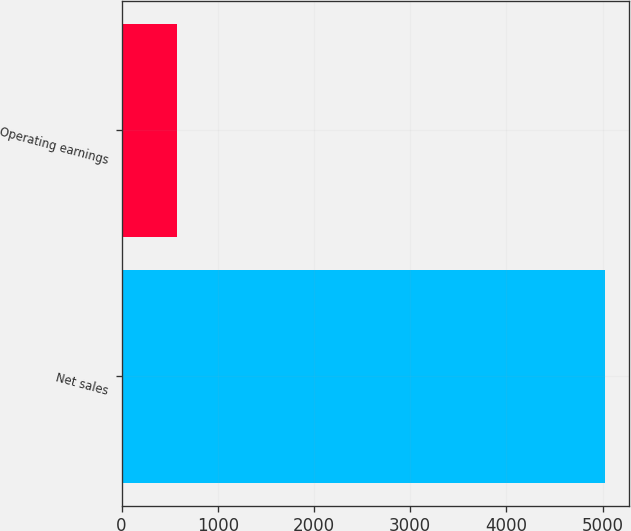<chart> <loc_0><loc_0><loc_500><loc_500><bar_chart><fcel>Net sales<fcel>Operating earnings<nl><fcel>5021<fcel>576<nl></chart> 